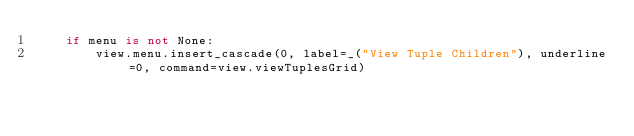Convert code to text. <code><loc_0><loc_0><loc_500><loc_500><_Python_>    if menu is not None:
        view.menu.insert_cascade(0, label=_("View Tuple Children"), underline=0, command=view.viewTuplesGrid)</code> 